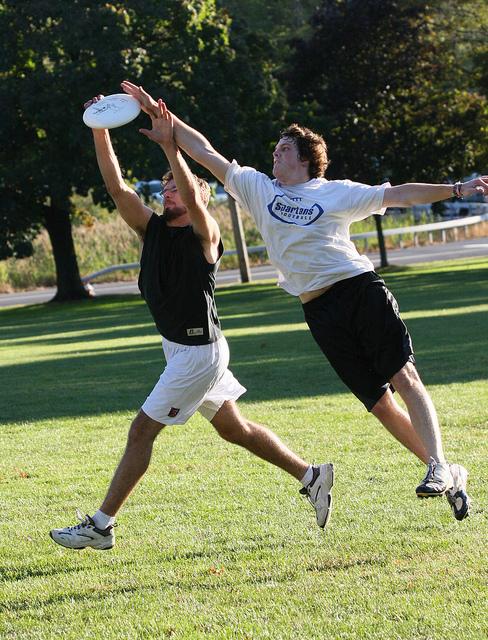Would you see the man on the right is playing aggressively?
Short answer required. Yes. How many people are shown wearing hats?
Answer briefly. 0. What color is the disk?
Give a very brief answer. White. Which person initially caught the frisbee?
Concise answer only. Person on right. 